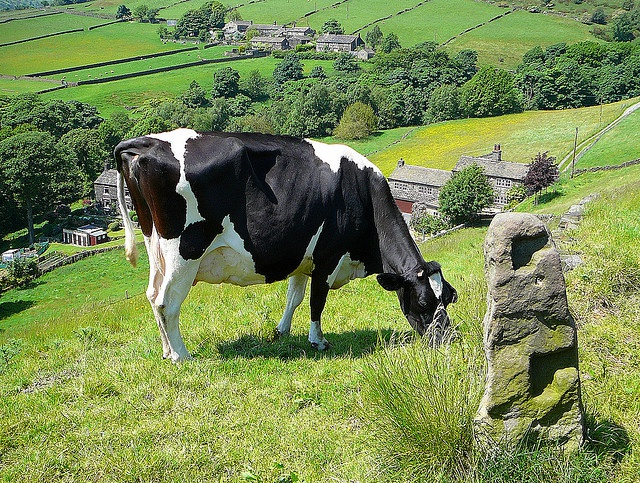Describe the objects in this image and their specific colors. I can see a cow in teal, black, gray, white, and darkgray tones in this image. 